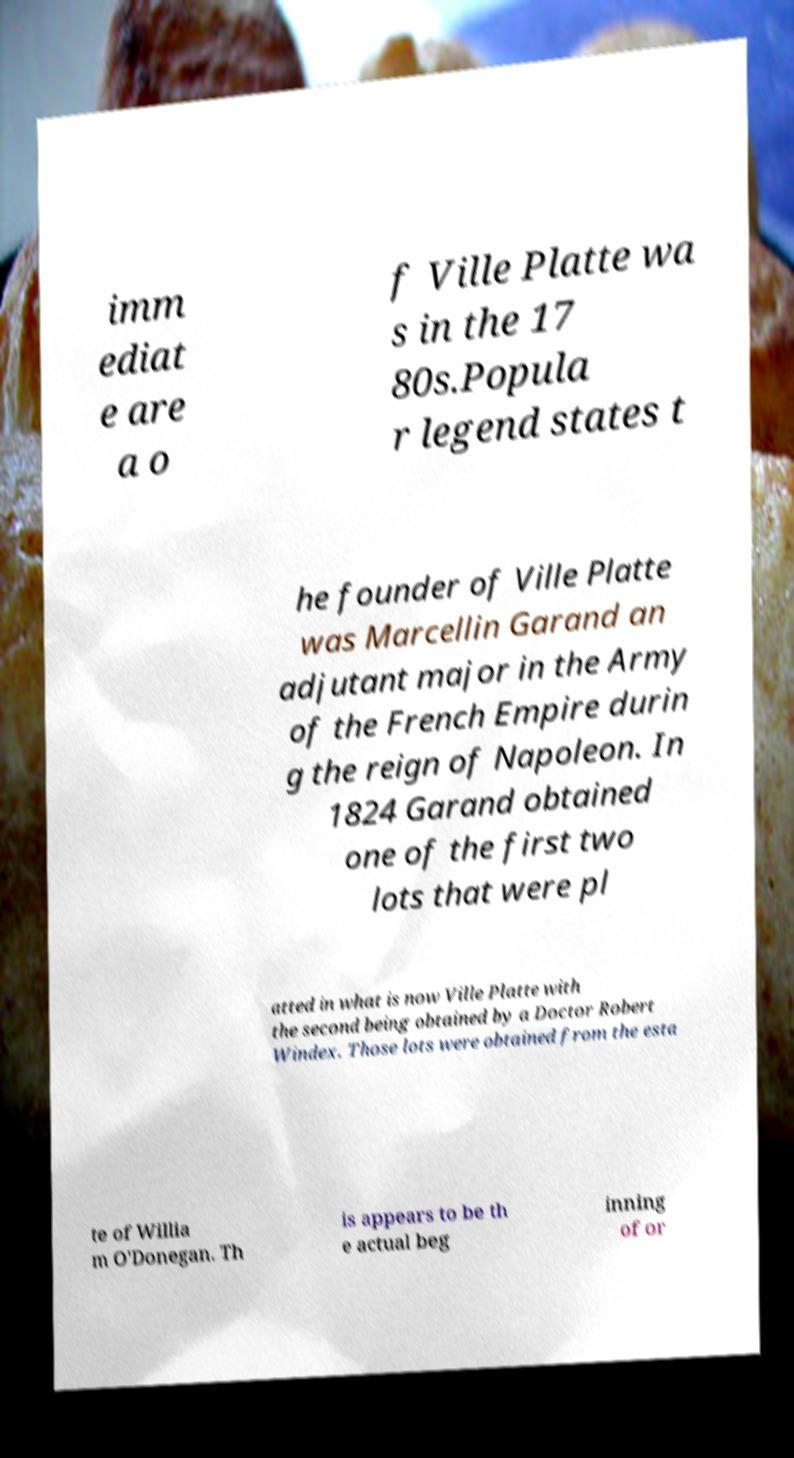Could you extract and type out the text from this image? imm ediat e are a o f Ville Platte wa s in the 17 80s.Popula r legend states t he founder of Ville Platte was Marcellin Garand an adjutant major in the Army of the French Empire durin g the reign of Napoleon. In 1824 Garand obtained one of the first two lots that were pl atted in what is now Ville Platte with the second being obtained by a Doctor Robert Windex. Those lots were obtained from the esta te of Willia m O'Donegan. Th is appears to be th e actual beg inning of or 